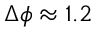<formula> <loc_0><loc_0><loc_500><loc_500>\Delta \phi \approx 1 . 2</formula> 